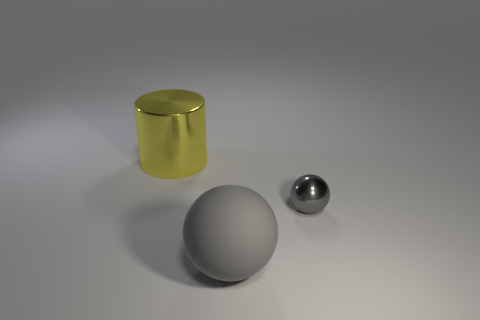Do the gray rubber sphere and the metal object in front of the large shiny object have the same size? While it is difficult to ascertain scale and size with absolute certainty without additional context or measurable references, based on the visual perspective provided, the gray rubber sphere appears larger than the metallic object situated closer to the foreground. Objects often appear smaller when farther away due to perspective, but given their relative proximity and the visual cues in the image, it is reasonable to infer that the gray sphere is indeed larger than the metal object. 